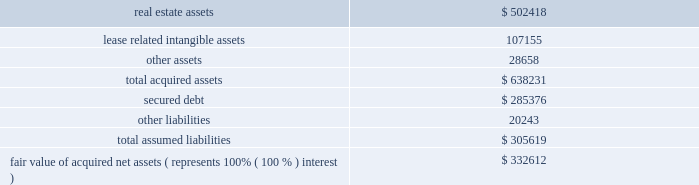57 annual report 2010 duke realty corporation | | level 2 inputs are inputs other than quoted prices included in level 1 that are observable for the asset or liability , either directly or indirectly .
Level 2 inputs may include quoted prices for similar assets and liabilities in active markets , as well as inputs that are observable for the asset or liability ( other than quoted prices ) , such as interest rates and yield curves that are observable at commonly quoted intervals .
Level 3 inputs are unobservable inputs for the asset or liability , which are typically based on an entity 2019s own assumptions , as there is little , if any , related market activity .
In instances where the determination of the fair value measurement is based on inputs from different levels of the fair value hierarchy , the level in the fair value hierarchy within which the entire fair value measurement falls is based on the lowest level input that is significant to the fair value measurement in its entirety .
Our assessment of the significance of a particular input to the fair value measurement in its entirety requires judgment and considers factors specific to the asset or liability .
Use of estimates the preparation of the financial statements requires management to make a number of estimates and assumptions that affect the reported amount of assets and liabilities and the disclosure of contingent assets and liabilities at the date of the financial statements and the reported amounts of revenues and expenses during the period .
The most significant estimates , as discussed within our summary of significant accounting policies , pertain to the critical assumptions utilized in testing real estate assets for impairment as well as in estimating the fair value of real estate assets when an impairment event has taken place .
Actual results could differ from those estimates .
( 3 ) significant acquisitions and dispositions 2010 acquisition of remaining interest in dugan realty , l.l.c .
On july 1 , 2010 , we acquired our joint venture partner 2019s 50% ( 50 % ) interest in dugan realty , l.l.c .
( 201cdugan 201d ) , a real estate joint venture that we had previously accounted for using the equity method , for a payment of $ 166.7 million .
Dugan held $ 28.1 million of cash at the time of acquisition , which resulted in a net cash outlay of $ 138.6 million .
As the result of this transaction we obtained 100% ( 100 % ) of dugan 2019s membership interests .
At the date of acquisition , dugan owned 106 industrial buildings totaling 20.8 million square feet and 63 net acres of undeveloped land located in midwest and southeast markets .
Dugan had a secured loan with a face value of $ 195.4 million due in october 2010 , which was repaid at its scheduled maturity date , and a secured loan with a face value of $ 87.6 million due in october 2012 ( see note 8 ) .
The acquisition was completed in order to pursue our strategy to increase our overall allocation to industrial real estate assets .
The table summarizes our allocation of the fair value of amounts recognized for each major class of assets and liabilities ( in thousands ) : .
Fair value of acquired net assets ( represents 100% ( 100 % ) interest ) $ 332612 we previously managed and performed other ancillary services for dugan 2019s properties and , as a result , dugan had no employees of its own and no .
What is the total equity value of dugan realty llc , in million dollar? 
Computations: (166.7 * 2)
Answer: 333.4. 